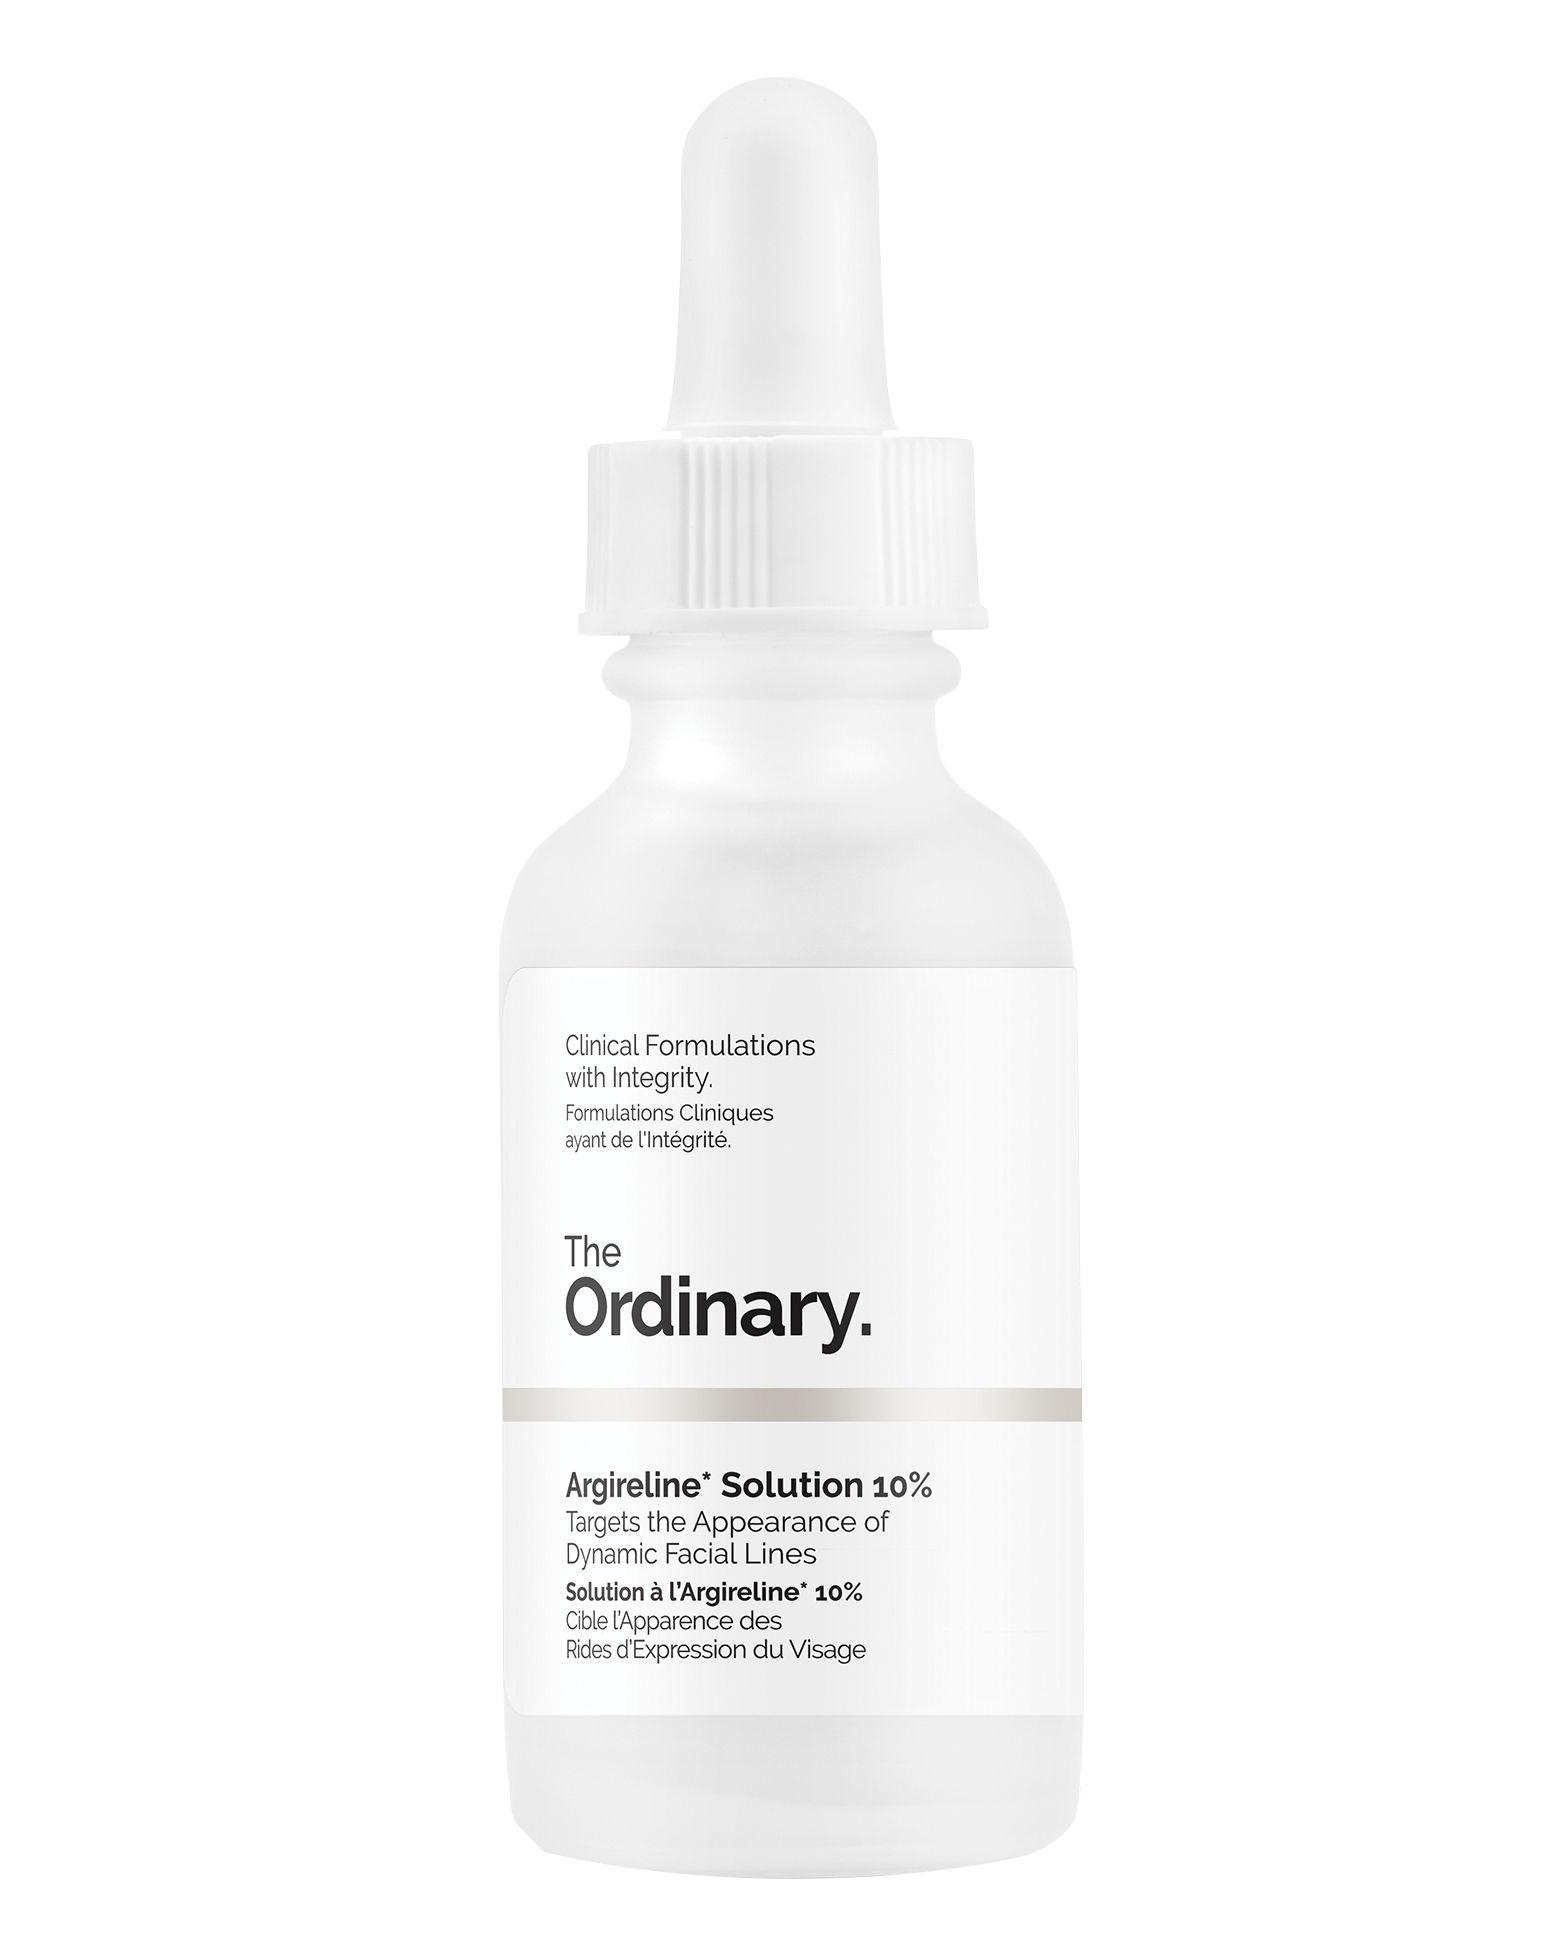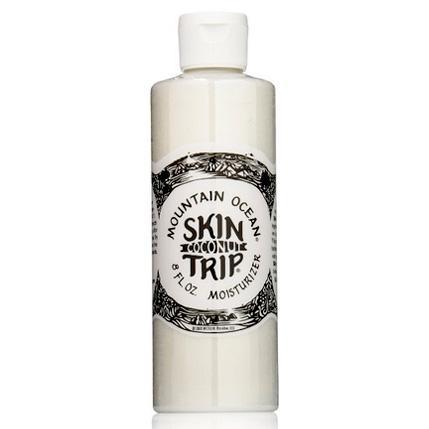The first image is the image on the left, the second image is the image on the right. For the images displayed, is the sentence "One of the bottles has a pump cap." factually correct? Answer yes or no. No. The first image is the image on the left, the second image is the image on the right. Analyze the images presented: Is the assertion "One of the bottles has a pump dispenser on top." valid? Answer yes or no. No. 